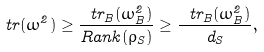Convert formula to latex. <formula><loc_0><loc_0><loc_500><loc_500>\ t r ( \omega ^ { 2 } ) \geq \frac { \ t r _ { B } ( \omega _ { B } ^ { 2 } ) } { R a n k ( \rho _ { S } ) } \geq \frac { \ t r _ { B } ( \omega _ { B } ^ { 2 } ) } { d _ { S } } ,</formula> 